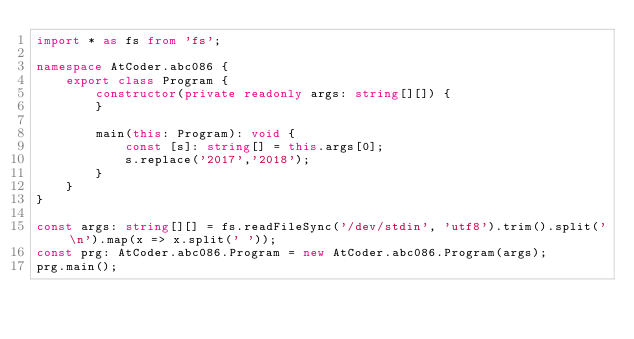<code> <loc_0><loc_0><loc_500><loc_500><_TypeScript_>import * as fs from 'fs';

namespace AtCoder.abc086 {
    export class Program {
        constructor(private readonly args: string[][]) {
        }

        main(this: Program): void {
            const [s]: string[] = this.args[0];
            s.replace('2017','2018');
        }
    }
}

const args: string[][] = fs.readFileSync('/dev/stdin', 'utf8').trim().split('\n').map(x => x.split(' '));
const prg: AtCoder.abc086.Program = new AtCoder.abc086.Program(args);
prg.main();
</code> 